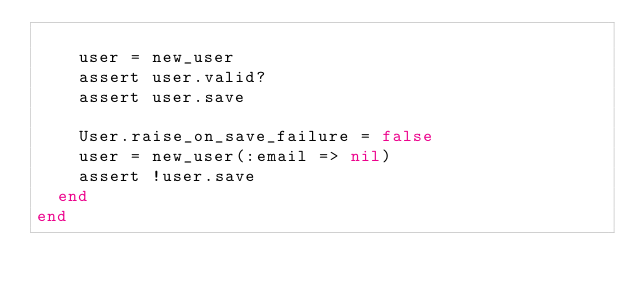Convert code to text. <code><loc_0><loc_0><loc_500><loc_500><_Ruby_>
    user = new_user
    assert user.valid?
    assert user.save

    User.raise_on_save_failure = false
    user = new_user(:email => nil)
    assert !user.save
  end
end
</code> 